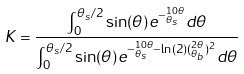Convert formula to latex. <formula><loc_0><loc_0><loc_500><loc_500>K = \frac { { \int ^ { \theta _ { s } / 2 } _ { 0 } \sin ( \theta ) e ^ { - ^ { 1 0 \theta } _ { \theta _ { s } } } d \theta } } { { \int ^ { \theta _ { s } / 2 } _ { 0 } \sin ( \theta ) e ^ { - ^ { 1 0 \theta } _ { \theta _ { s } } - \ln ( 2 ) ( ^ { 2 \theta } _ { \theta _ { b } } ) ^ { 2 } } d \theta } }</formula> 